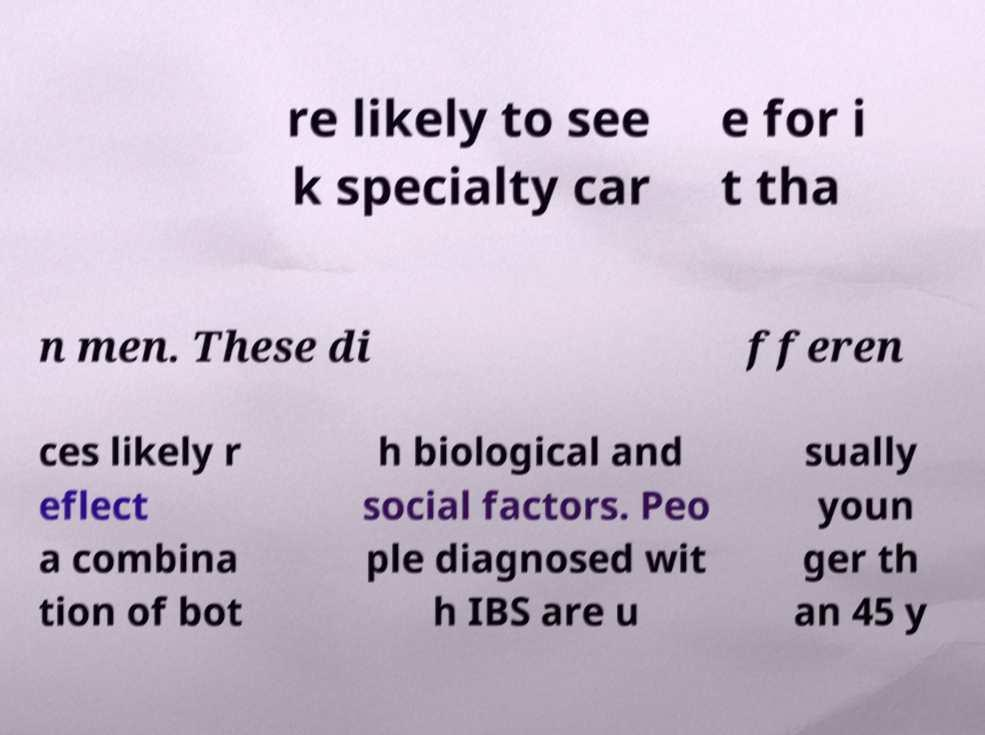Please read and relay the text visible in this image. What does it say? re likely to see k specialty car e for i t tha n men. These di fferen ces likely r eflect a combina tion of bot h biological and social factors. Peo ple diagnosed wit h IBS are u sually youn ger th an 45 y 